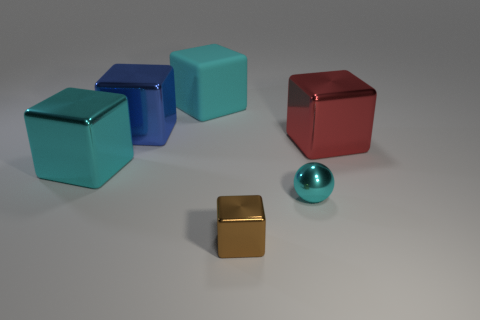What is the material of the blue object that is the same shape as the tiny brown thing?
Ensure brevity in your answer.  Metal. How big is the sphere in front of the cyan rubber object that is behind the brown thing?
Your answer should be very brief. Small. Is there a red matte object?
Your answer should be very brief. No. There is a big thing that is right of the blue shiny thing and behind the large red shiny cube; what is its material?
Offer a very short reply. Rubber. Are there more cyan metal objects that are on the left side of the cyan sphere than tiny cyan balls left of the brown block?
Your answer should be very brief. Yes. Are there any blue objects of the same size as the red shiny object?
Provide a succinct answer. Yes. What size is the cube on the right side of the small metal block in front of the big object to the right of the big rubber thing?
Offer a terse response. Large. What color is the large matte object?
Make the answer very short. Cyan. Is the number of big objects left of the tiny cyan sphere greater than the number of tiny cyan metal spheres?
Keep it short and to the point. Yes. How many cyan objects are to the right of the blue cube?
Ensure brevity in your answer.  2. 